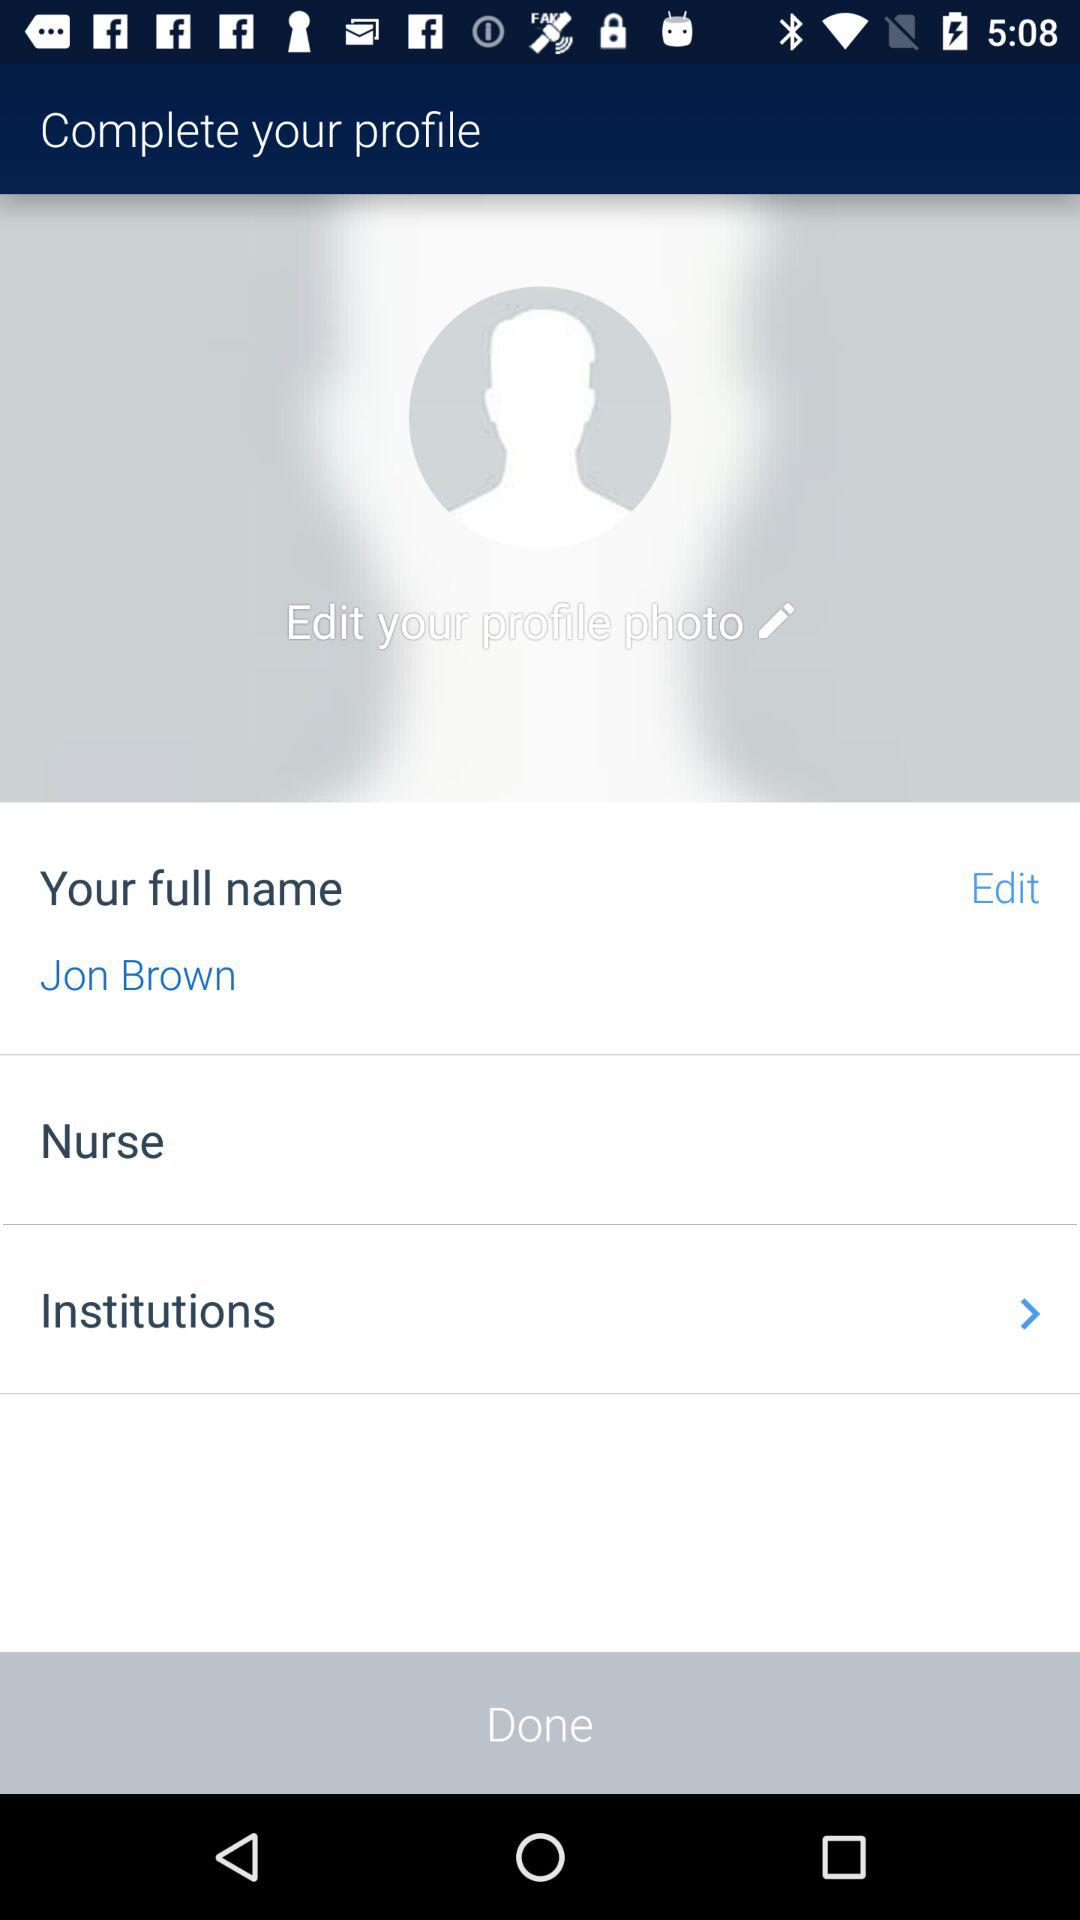What is the full name? The full name is Jon Brown. 